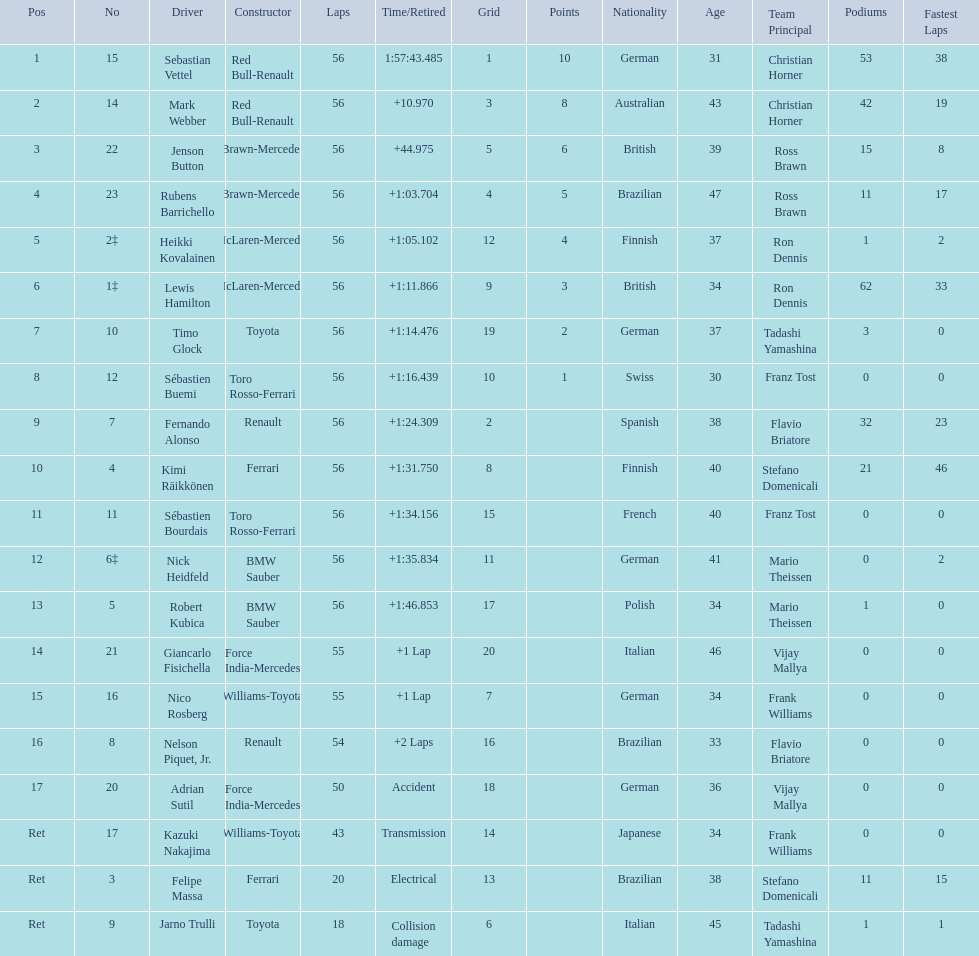Who are all of the drivers? Sebastian Vettel, Mark Webber, Jenson Button, Rubens Barrichello, Heikki Kovalainen, Lewis Hamilton, Timo Glock, Sébastien Buemi, Fernando Alonso, Kimi Räikkönen, Sébastien Bourdais, Nick Heidfeld, Robert Kubica, Giancarlo Fisichella, Nico Rosberg, Nelson Piquet, Jr., Adrian Sutil, Kazuki Nakajima, Felipe Massa, Jarno Trulli. Who were their constructors? Red Bull-Renault, Red Bull-Renault, Brawn-Mercedes, Brawn-Mercedes, McLaren-Mercedes, McLaren-Mercedes, Toyota, Toro Rosso-Ferrari, Renault, Ferrari, Toro Rosso-Ferrari, BMW Sauber, BMW Sauber, Force India-Mercedes, Williams-Toyota, Renault, Force India-Mercedes, Williams-Toyota, Ferrari, Toyota. Who was the first listed driver to not drive a ferrari?? Sebastian Vettel. 